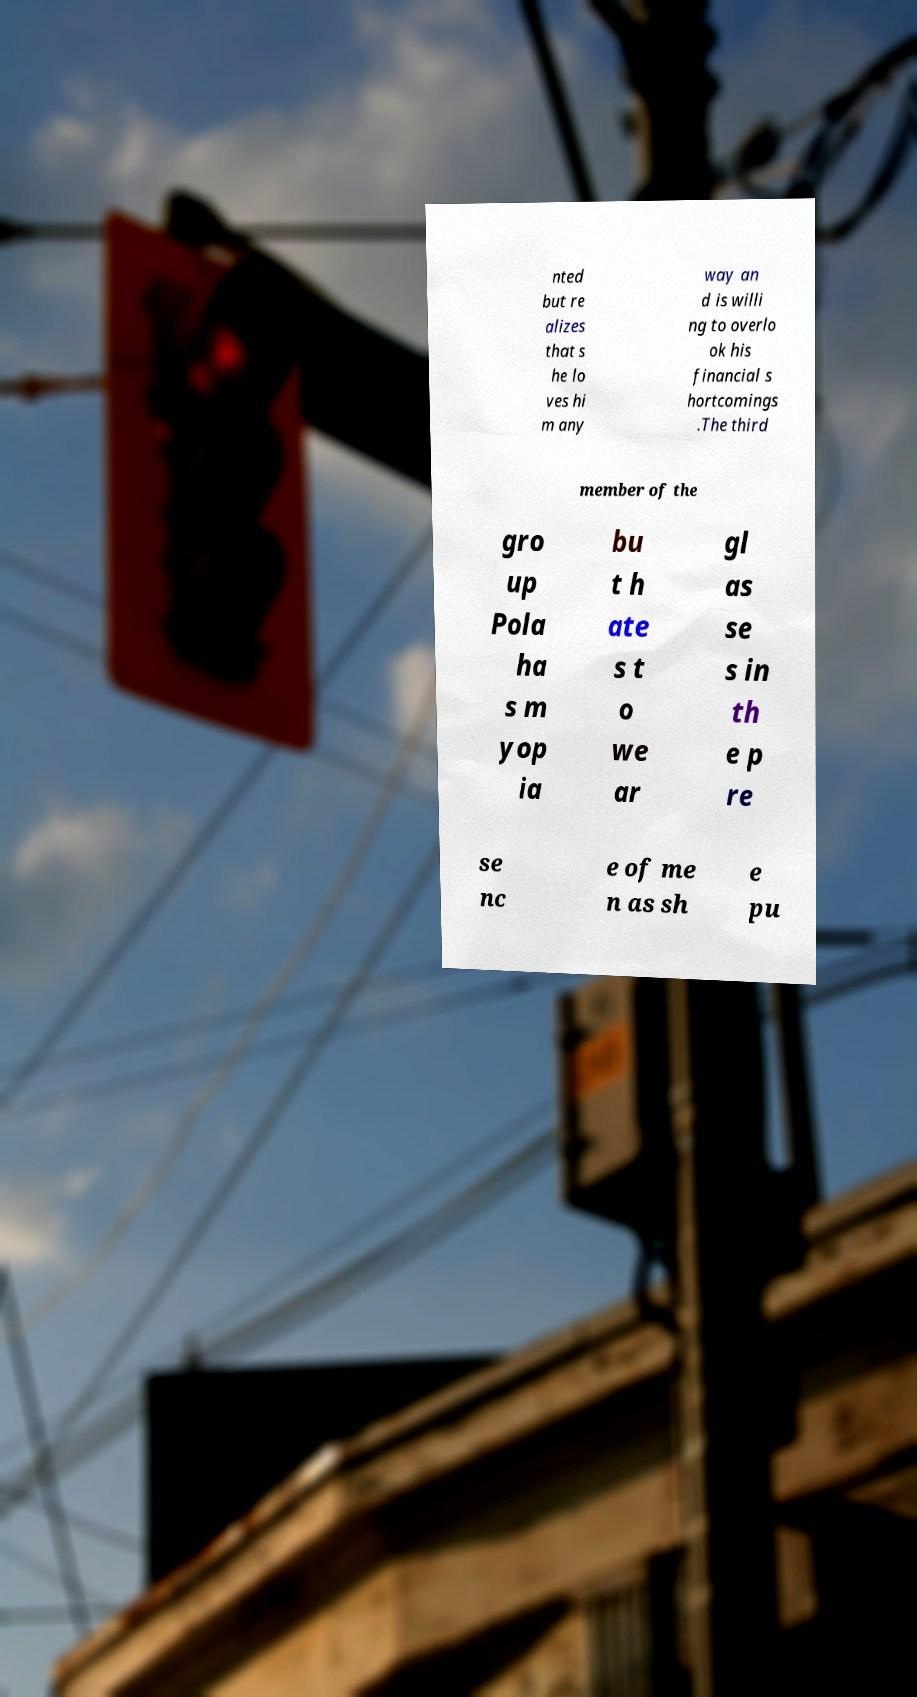Please read and relay the text visible in this image. What does it say? nted but re alizes that s he lo ves hi m any way an d is willi ng to overlo ok his financial s hortcomings .The third member of the gro up Pola ha s m yop ia bu t h ate s t o we ar gl as se s in th e p re se nc e of me n as sh e pu 